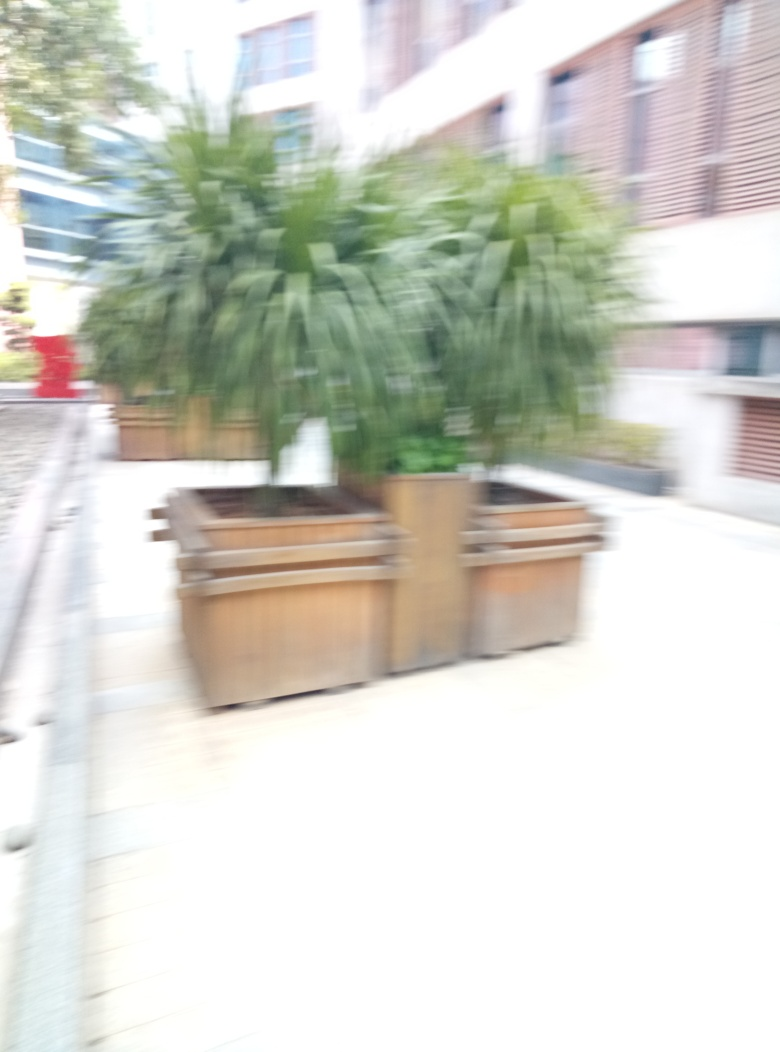Why is the outline of the potted plant blurred?
A. The image is perfectly focused
B. The image is out of focus
C. The camera moved during capture
D. The plant was moving
Answer with the option's letter from the given choices directly.
 B. 